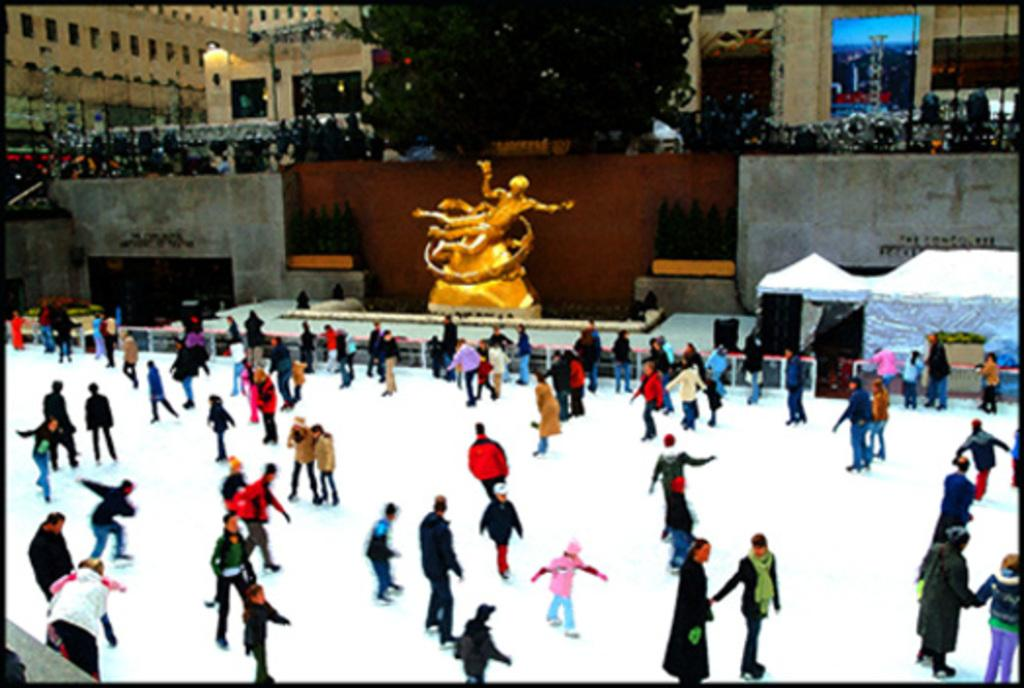Who or what can be seen in the image? There are people in the image. What is the weather like in the image? There is snow in the image, indicating a cold or wintery environment. What is the statue in the image made of? The provided facts do not specify the material of the statue. What type of structure is visible in the image? There is a building in the image. What type of rhythm can be heard in the image? There is no audible rhythm present in the image, as it is a still photograph. 